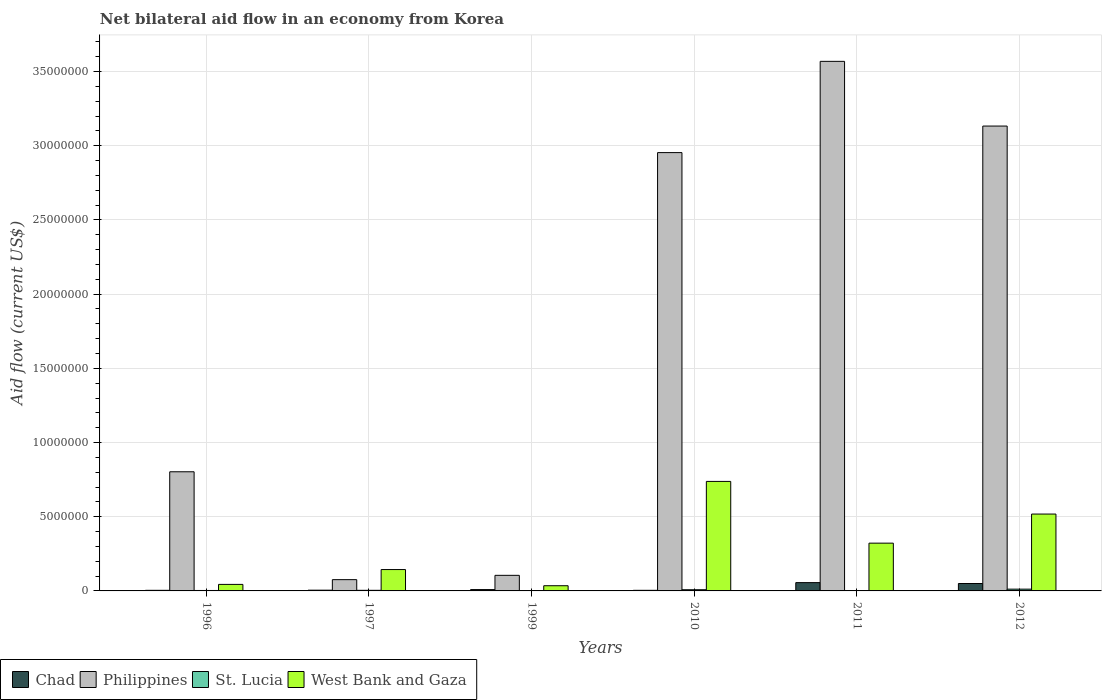How many different coloured bars are there?
Your answer should be very brief. 4. Are the number of bars per tick equal to the number of legend labels?
Keep it short and to the point. Yes. How many bars are there on the 1st tick from the left?
Offer a very short reply. 4. What is the label of the 1st group of bars from the left?
Your response must be concise. 1996. In how many cases, is the number of bars for a given year not equal to the number of legend labels?
Your response must be concise. 0. In which year was the net bilateral aid flow in Philippines maximum?
Give a very brief answer. 2011. In which year was the net bilateral aid flow in West Bank and Gaza minimum?
Offer a very short reply. 1999. What is the total net bilateral aid flow in West Bank and Gaza in the graph?
Provide a succinct answer. 1.80e+07. What is the difference between the net bilateral aid flow in Chad in 1997 and that in 2011?
Provide a succinct answer. -5.10e+05. What is the difference between the net bilateral aid flow in Chad in 1997 and the net bilateral aid flow in St. Lucia in 2012?
Keep it short and to the point. -7.00e+04. What is the average net bilateral aid flow in Philippines per year?
Provide a short and direct response. 1.77e+07. In the year 1997, what is the difference between the net bilateral aid flow in West Bank and Gaza and net bilateral aid flow in Philippines?
Provide a short and direct response. 6.80e+05. In how many years, is the net bilateral aid flow in Chad greater than 18000000 US$?
Your answer should be compact. 0. What is the ratio of the net bilateral aid flow in Chad in 1996 to that in 1999?
Make the answer very short. 0.44. Is the difference between the net bilateral aid flow in West Bank and Gaza in 1996 and 2010 greater than the difference between the net bilateral aid flow in Philippines in 1996 and 2010?
Keep it short and to the point. Yes. What is the difference between the highest and the second highest net bilateral aid flow in Philippines?
Give a very brief answer. 4.36e+06. What is the difference between the highest and the lowest net bilateral aid flow in Philippines?
Your answer should be very brief. 3.49e+07. In how many years, is the net bilateral aid flow in Chad greater than the average net bilateral aid flow in Chad taken over all years?
Make the answer very short. 2. Is the sum of the net bilateral aid flow in Philippines in 1997 and 1999 greater than the maximum net bilateral aid flow in Chad across all years?
Give a very brief answer. Yes. Is it the case that in every year, the sum of the net bilateral aid flow in Philippines and net bilateral aid flow in St. Lucia is greater than the sum of net bilateral aid flow in West Bank and Gaza and net bilateral aid flow in Chad?
Keep it short and to the point. No. What does the 1st bar from the left in 1999 represents?
Your response must be concise. Chad. What does the 1st bar from the right in 1996 represents?
Provide a succinct answer. West Bank and Gaza. Is it the case that in every year, the sum of the net bilateral aid flow in Chad and net bilateral aid flow in West Bank and Gaza is greater than the net bilateral aid flow in Philippines?
Ensure brevity in your answer.  No. Are all the bars in the graph horizontal?
Ensure brevity in your answer.  No. How many years are there in the graph?
Offer a very short reply. 6. What is the difference between two consecutive major ticks on the Y-axis?
Your response must be concise. 5.00e+06. Does the graph contain any zero values?
Give a very brief answer. No. Where does the legend appear in the graph?
Provide a short and direct response. Bottom left. How many legend labels are there?
Make the answer very short. 4. How are the legend labels stacked?
Provide a short and direct response. Horizontal. What is the title of the graph?
Your answer should be very brief. Net bilateral aid flow in an economy from Korea. What is the Aid flow (current US$) of Philippines in 1996?
Make the answer very short. 8.03e+06. What is the Aid flow (current US$) in Philippines in 1997?
Keep it short and to the point. 7.60e+05. What is the Aid flow (current US$) of West Bank and Gaza in 1997?
Make the answer very short. 1.44e+06. What is the Aid flow (current US$) of Philippines in 1999?
Offer a very short reply. 1.05e+06. What is the Aid flow (current US$) in Philippines in 2010?
Provide a succinct answer. 2.95e+07. What is the Aid flow (current US$) of St. Lucia in 2010?
Offer a terse response. 8.00e+04. What is the Aid flow (current US$) in West Bank and Gaza in 2010?
Offer a terse response. 7.38e+06. What is the Aid flow (current US$) in Chad in 2011?
Your response must be concise. 5.60e+05. What is the Aid flow (current US$) in Philippines in 2011?
Make the answer very short. 3.57e+07. What is the Aid flow (current US$) in St. Lucia in 2011?
Ensure brevity in your answer.  10000. What is the Aid flow (current US$) of West Bank and Gaza in 2011?
Provide a short and direct response. 3.22e+06. What is the Aid flow (current US$) in Chad in 2012?
Your answer should be compact. 5.00e+05. What is the Aid flow (current US$) of Philippines in 2012?
Your answer should be very brief. 3.13e+07. What is the Aid flow (current US$) of St. Lucia in 2012?
Provide a short and direct response. 1.20e+05. What is the Aid flow (current US$) in West Bank and Gaza in 2012?
Provide a short and direct response. 5.18e+06. Across all years, what is the maximum Aid flow (current US$) in Chad?
Provide a short and direct response. 5.60e+05. Across all years, what is the maximum Aid flow (current US$) of Philippines?
Make the answer very short. 3.57e+07. Across all years, what is the maximum Aid flow (current US$) in West Bank and Gaza?
Provide a short and direct response. 7.38e+06. Across all years, what is the minimum Aid flow (current US$) of Philippines?
Offer a very short reply. 7.60e+05. What is the total Aid flow (current US$) in Chad in the graph?
Provide a short and direct response. 1.28e+06. What is the total Aid flow (current US$) of Philippines in the graph?
Offer a very short reply. 1.06e+08. What is the total Aid flow (current US$) of St. Lucia in the graph?
Your answer should be very brief. 3.00e+05. What is the total Aid flow (current US$) of West Bank and Gaza in the graph?
Keep it short and to the point. 1.80e+07. What is the difference between the Aid flow (current US$) of Philippines in 1996 and that in 1997?
Your response must be concise. 7.27e+06. What is the difference between the Aid flow (current US$) of St. Lucia in 1996 and that in 1997?
Give a very brief answer. -10000. What is the difference between the Aid flow (current US$) in West Bank and Gaza in 1996 and that in 1997?
Keep it short and to the point. -1.00e+06. What is the difference between the Aid flow (current US$) of Chad in 1996 and that in 1999?
Provide a short and direct response. -5.00e+04. What is the difference between the Aid flow (current US$) of Philippines in 1996 and that in 1999?
Ensure brevity in your answer.  6.98e+06. What is the difference between the Aid flow (current US$) in Chad in 1996 and that in 2010?
Provide a succinct answer. 0. What is the difference between the Aid flow (current US$) in Philippines in 1996 and that in 2010?
Offer a very short reply. -2.15e+07. What is the difference between the Aid flow (current US$) in St. Lucia in 1996 and that in 2010?
Offer a very short reply. -5.00e+04. What is the difference between the Aid flow (current US$) in West Bank and Gaza in 1996 and that in 2010?
Your answer should be very brief. -6.94e+06. What is the difference between the Aid flow (current US$) of Chad in 1996 and that in 2011?
Offer a very short reply. -5.20e+05. What is the difference between the Aid flow (current US$) in Philippines in 1996 and that in 2011?
Offer a very short reply. -2.77e+07. What is the difference between the Aid flow (current US$) of St. Lucia in 1996 and that in 2011?
Your answer should be very brief. 2.00e+04. What is the difference between the Aid flow (current US$) in West Bank and Gaza in 1996 and that in 2011?
Provide a short and direct response. -2.78e+06. What is the difference between the Aid flow (current US$) of Chad in 1996 and that in 2012?
Make the answer very short. -4.60e+05. What is the difference between the Aid flow (current US$) in Philippines in 1996 and that in 2012?
Ensure brevity in your answer.  -2.33e+07. What is the difference between the Aid flow (current US$) of St. Lucia in 1996 and that in 2012?
Give a very brief answer. -9.00e+04. What is the difference between the Aid flow (current US$) in West Bank and Gaza in 1996 and that in 2012?
Your response must be concise. -4.74e+06. What is the difference between the Aid flow (current US$) of Chad in 1997 and that in 1999?
Your answer should be compact. -4.00e+04. What is the difference between the Aid flow (current US$) of West Bank and Gaza in 1997 and that in 1999?
Provide a succinct answer. 1.09e+06. What is the difference between the Aid flow (current US$) of Chad in 1997 and that in 2010?
Offer a terse response. 10000. What is the difference between the Aid flow (current US$) in Philippines in 1997 and that in 2010?
Keep it short and to the point. -2.88e+07. What is the difference between the Aid flow (current US$) of West Bank and Gaza in 1997 and that in 2010?
Give a very brief answer. -5.94e+06. What is the difference between the Aid flow (current US$) of Chad in 1997 and that in 2011?
Make the answer very short. -5.10e+05. What is the difference between the Aid flow (current US$) of Philippines in 1997 and that in 2011?
Make the answer very short. -3.49e+07. What is the difference between the Aid flow (current US$) of West Bank and Gaza in 1997 and that in 2011?
Offer a very short reply. -1.78e+06. What is the difference between the Aid flow (current US$) of Chad in 1997 and that in 2012?
Provide a short and direct response. -4.50e+05. What is the difference between the Aid flow (current US$) in Philippines in 1997 and that in 2012?
Provide a short and direct response. -3.06e+07. What is the difference between the Aid flow (current US$) of West Bank and Gaza in 1997 and that in 2012?
Your answer should be very brief. -3.74e+06. What is the difference between the Aid flow (current US$) in Philippines in 1999 and that in 2010?
Your response must be concise. -2.85e+07. What is the difference between the Aid flow (current US$) of St. Lucia in 1999 and that in 2010?
Make the answer very short. -6.00e+04. What is the difference between the Aid flow (current US$) of West Bank and Gaza in 1999 and that in 2010?
Make the answer very short. -7.03e+06. What is the difference between the Aid flow (current US$) in Chad in 1999 and that in 2011?
Give a very brief answer. -4.70e+05. What is the difference between the Aid flow (current US$) in Philippines in 1999 and that in 2011?
Your answer should be compact. -3.46e+07. What is the difference between the Aid flow (current US$) of St. Lucia in 1999 and that in 2011?
Offer a terse response. 10000. What is the difference between the Aid flow (current US$) of West Bank and Gaza in 1999 and that in 2011?
Provide a short and direct response. -2.87e+06. What is the difference between the Aid flow (current US$) in Chad in 1999 and that in 2012?
Make the answer very short. -4.10e+05. What is the difference between the Aid flow (current US$) of Philippines in 1999 and that in 2012?
Keep it short and to the point. -3.03e+07. What is the difference between the Aid flow (current US$) of West Bank and Gaza in 1999 and that in 2012?
Your answer should be very brief. -4.83e+06. What is the difference between the Aid flow (current US$) of Chad in 2010 and that in 2011?
Your answer should be compact. -5.20e+05. What is the difference between the Aid flow (current US$) of Philippines in 2010 and that in 2011?
Provide a succinct answer. -6.15e+06. What is the difference between the Aid flow (current US$) in St. Lucia in 2010 and that in 2011?
Provide a succinct answer. 7.00e+04. What is the difference between the Aid flow (current US$) of West Bank and Gaza in 2010 and that in 2011?
Your answer should be very brief. 4.16e+06. What is the difference between the Aid flow (current US$) in Chad in 2010 and that in 2012?
Ensure brevity in your answer.  -4.60e+05. What is the difference between the Aid flow (current US$) of Philippines in 2010 and that in 2012?
Your response must be concise. -1.79e+06. What is the difference between the Aid flow (current US$) of West Bank and Gaza in 2010 and that in 2012?
Offer a very short reply. 2.20e+06. What is the difference between the Aid flow (current US$) in Philippines in 2011 and that in 2012?
Make the answer very short. 4.36e+06. What is the difference between the Aid flow (current US$) in West Bank and Gaza in 2011 and that in 2012?
Make the answer very short. -1.96e+06. What is the difference between the Aid flow (current US$) in Chad in 1996 and the Aid flow (current US$) in Philippines in 1997?
Your answer should be compact. -7.20e+05. What is the difference between the Aid flow (current US$) in Chad in 1996 and the Aid flow (current US$) in St. Lucia in 1997?
Give a very brief answer. 0. What is the difference between the Aid flow (current US$) of Chad in 1996 and the Aid flow (current US$) of West Bank and Gaza in 1997?
Offer a very short reply. -1.40e+06. What is the difference between the Aid flow (current US$) in Philippines in 1996 and the Aid flow (current US$) in St. Lucia in 1997?
Your response must be concise. 7.99e+06. What is the difference between the Aid flow (current US$) in Philippines in 1996 and the Aid flow (current US$) in West Bank and Gaza in 1997?
Ensure brevity in your answer.  6.59e+06. What is the difference between the Aid flow (current US$) in St. Lucia in 1996 and the Aid flow (current US$) in West Bank and Gaza in 1997?
Keep it short and to the point. -1.41e+06. What is the difference between the Aid flow (current US$) in Chad in 1996 and the Aid flow (current US$) in Philippines in 1999?
Offer a terse response. -1.01e+06. What is the difference between the Aid flow (current US$) of Chad in 1996 and the Aid flow (current US$) of West Bank and Gaza in 1999?
Give a very brief answer. -3.10e+05. What is the difference between the Aid flow (current US$) in Philippines in 1996 and the Aid flow (current US$) in St. Lucia in 1999?
Offer a terse response. 8.01e+06. What is the difference between the Aid flow (current US$) of Philippines in 1996 and the Aid flow (current US$) of West Bank and Gaza in 1999?
Keep it short and to the point. 7.68e+06. What is the difference between the Aid flow (current US$) in St. Lucia in 1996 and the Aid flow (current US$) in West Bank and Gaza in 1999?
Your answer should be compact. -3.20e+05. What is the difference between the Aid flow (current US$) in Chad in 1996 and the Aid flow (current US$) in Philippines in 2010?
Your response must be concise. -2.95e+07. What is the difference between the Aid flow (current US$) of Chad in 1996 and the Aid flow (current US$) of West Bank and Gaza in 2010?
Provide a succinct answer. -7.34e+06. What is the difference between the Aid flow (current US$) in Philippines in 1996 and the Aid flow (current US$) in St. Lucia in 2010?
Provide a short and direct response. 7.95e+06. What is the difference between the Aid flow (current US$) in Philippines in 1996 and the Aid flow (current US$) in West Bank and Gaza in 2010?
Your answer should be compact. 6.50e+05. What is the difference between the Aid flow (current US$) in St. Lucia in 1996 and the Aid flow (current US$) in West Bank and Gaza in 2010?
Offer a terse response. -7.35e+06. What is the difference between the Aid flow (current US$) in Chad in 1996 and the Aid flow (current US$) in Philippines in 2011?
Provide a short and direct response. -3.56e+07. What is the difference between the Aid flow (current US$) of Chad in 1996 and the Aid flow (current US$) of West Bank and Gaza in 2011?
Provide a short and direct response. -3.18e+06. What is the difference between the Aid flow (current US$) in Philippines in 1996 and the Aid flow (current US$) in St. Lucia in 2011?
Your answer should be compact. 8.02e+06. What is the difference between the Aid flow (current US$) in Philippines in 1996 and the Aid flow (current US$) in West Bank and Gaza in 2011?
Provide a short and direct response. 4.81e+06. What is the difference between the Aid flow (current US$) of St. Lucia in 1996 and the Aid flow (current US$) of West Bank and Gaza in 2011?
Provide a short and direct response. -3.19e+06. What is the difference between the Aid flow (current US$) in Chad in 1996 and the Aid flow (current US$) in Philippines in 2012?
Offer a terse response. -3.13e+07. What is the difference between the Aid flow (current US$) of Chad in 1996 and the Aid flow (current US$) of West Bank and Gaza in 2012?
Your answer should be very brief. -5.14e+06. What is the difference between the Aid flow (current US$) of Philippines in 1996 and the Aid flow (current US$) of St. Lucia in 2012?
Provide a short and direct response. 7.91e+06. What is the difference between the Aid flow (current US$) in Philippines in 1996 and the Aid flow (current US$) in West Bank and Gaza in 2012?
Offer a terse response. 2.85e+06. What is the difference between the Aid flow (current US$) in St. Lucia in 1996 and the Aid flow (current US$) in West Bank and Gaza in 2012?
Offer a terse response. -5.15e+06. What is the difference between the Aid flow (current US$) in Chad in 1997 and the Aid flow (current US$) in St. Lucia in 1999?
Provide a succinct answer. 3.00e+04. What is the difference between the Aid flow (current US$) in Chad in 1997 and the Aid flow (current US$) in West Bank and Gaza in 1999?
Ensure brevity in your answer.  -3.00e+05. What is the difference between the Aid flow (current US$) in Philippines in 1997 and the Aid flow (current US$) in St. Lucia in 1999?
Offer a very short reply. 7.40e+05. What is the difference between the Aid flow (current US$) in St. Lucia in 1997 and the Aid flow (current US$) in West Bank and Gaza in 1999?
Your answer should be very brief. -3.10e+05. What is the difference between the Aid flow (current US$) in Chad in 1997 and the Aid flow (current US$) in Philippines in 2010?
Ensure brevity in your answer.  -2.95e+07. What is the difference between the Aid flow (current US$) of Chad in 1997 and the Aid flow (current US$) of St. Lucia in 2010?
Provide a short and direct response. -3.00e+04. What is the difference between the Aid flow (current US$) of Chad in 1997 and the Aid flow (current US$) of West Bank and Gaza in 2010?
Your answer should be very brief. -7.33e+06. What is the difference between the Aid flow (current US$) of Philippines in 1997 and the Aid flow (current US$) of St. Lucia in 2010?
Offer a very short reply. 6.80e+05. What is the difference between the Aid flow (current US$) of Philippines in 1997 and the Aid flow (current US$) of West Bank and Gaza in 2010?
Your response must be concise. -6.62e+06. What is the difference between the Aid flow (current US$) of St. Lucia in 1997 and the Aid flow (current US$) of West Bank and Gaza in 2010?
Ensure brevity in your answer.  -7.34e+06. What is the difference between the Aid flow (current US$) in Chad in 1997 and the Aid flow (current US$) in Philippines in 2011?
Ensure brevity in your answer.  -3.56e+07. What is the difference between the Aid flow (current US$) in Chad in 1997 and the Aid flow (current US$) in West Bank and Gaza in 2011?
Offer a very short reply. -3.17e+06. What is the difference between the Aid flow (current US$) in Philippines in 1997 and the Aid flow (current US$) in St. Lucia in 2011?
Provide a short and direct response. 7.50e+05. What is the difference between the Aid flow (current US$) of Philippines in 1997 and the Aid flow (current US$) of West Bank and Gaza in 2011?
Your answer should be very brief. -2.46e+06. What is the difference between the Aid flow (current US$) in St. Lucia in 1997 and the Aid flow (current US$) in West Bank and Gaza in 2011?
Your response must be concise. -3.18e+06. What is the difference between the Aid flow (current US$) in Chad in 1997 and the Aid flow (current US$) in Philippines in 2012?
Provide a short and direct response. -3.13e+07. What is the difference between the Aid flow (current US$) of Chad in 1997 and the Aid flow (current US$) of St. Lucia in 2012?
Make the answer very short. -7.00e+04. What is the difference between the Aid flow (current US$) of Chad in 1997 and the Aid flow (current US$) of West Bank and Gaza in 2012?
Give a very brief answer. -5.13e+06. What is the difference between the Aid flow (current US$) in Philippines in 1997 and the Aid flow (current US$) in St. Lucia in 2012?
Give a very brief answer. 6.40e+05. What is the difference between the Aid flow (current US$) of Philippines in 1997 and the Aid flow (current US$) of West Bank and Gaza in 2012?
Make the answer very short. -4.42e+06. What is the difference between the Aid flow (current US$) in St. Lucia in 1997 and the Aid flow (current US$) in West Bank and Gaza in 2012?
Offer a terse response. -5.14e+06. What is the difference between the Aid flow (current US$) of Chad in 1999 and the Aid flow (current US$) of Philippines in 2010?
Offer a terse response. -2.94e+07. What is the difference between the Aid flow (current US$) in Chad in 1999 and the Aid flow (current US$) in St. Lucia in 2010?
Offer a very short reply. 10000. What is the difference between the Aid flow (current US$) in Chad in 1999 and the Aid flow (current US$) in West Bank and Gaza in 2010?
Make the answer very short. -7.29e+06. What is the difference between the Aid flow (current US$) of Philippines in 1999 and the Aid flow (current US$) of St. Lucia in 2010?
Give a very brief answer. 9.70e+05. What is the difference between the Aid flow (current US$) of Philippines in 1999 and the Aid flow (current US$) of West Bank and Gaza in 2010?
Make the answer very short. -6.33e+06. What is the difference between the Aid flow (current US$) of St. Lucia in 1999 and the Aid flow (current US$) of West Bank and Gaza in 2010?
Give a very brief answer. -7.36e+06. What is the difference between the Aid flow (current US$) in Chad in 1999 and the Aid flow (current US$) in Philippines in 2011?
Your answer should be very brief. -3.56e+07. What is the difference between the Aid flow (current US$) of Chad in 1999 and the Aid flow (current US$) of West Bank and Gaza in 2011?
Make the answer very short. -3.13e+06. What is the difference between the Aid flow (current US$) of Philippines in 1999 and the Aid flow (current US$) of St. Lucia in 2011?
Provide a succinct answer. 1.04e+06. What is the difference between the Aid flow (current US$) in Philippines in 1999 and the Aid flow (current US$) in West Bank and Gaza in 2011?
Make the answer very short. -2.17e+06. What is the difference between the Aid flow (current US$) of St. Lucia in 1999 and the Aid flow (current US$) of West Bank and Gaza in 2011?
Your response must be concise. -3.20e+06. What is the difference between the Aid flow (current US$) in Chad in 1999 and the Aid flow (current US$) in Philippines in 2012?
Provide a short and direct response. -3.12e+07. What is the difference between the Aid flow (current US$) in Chad in 1999 and the Aid flow (current US$) in St. Lucia in 2012?
Your response must be concise. -3.00e+04. What is the difference between the Aid flow (current US$) of Chad in 1999 and the Aid flow (current US$) of West Bank and Gaza in 2012?
Keep it short and to the point. -5.09e+06. What is the difference between the Aid flow (current US$) in Philippines in 1999 and the Aid flow (current US$) in St. Lucia in 2012?
Keep it short and to the point. 9.30e+05. What is the difference between the Aid flow (current US$) in Philippines in 1999 and the Aid flow (current US$) in West Bank and Gaza in 2012?
Provide a succinct answer. -4.13e+06. What is the difference between the Aid flow (current US$) in St. Lucia in 1999 and the Aid flow (current US$) in West Bank and Gaza in 2012?
Your answer should be very brief. -5.16e+06. What is the difference between the Aid flow (current US$) of Chad in 2010 and the Aid flow (current US$) of Philippines in 2011?
Ensure brevity in your answer.  -3.56e+07. What is the difference between the Aid flow (current US$) of Chad in 2010 and the Aid flow (current US$) of West Bank and Gaza in 2011?
Your response must be concise. -3.18e+06. What is the difference between the Aid flow (current US$) of Philippines in 2010 and the Aid flow (current US$) of St. Lucia in 2011?
Keep it short and to the point. 2.95e+07. What is the difference between the Aid flow (current US$) in Philippines in 2010 and the Aid flow (current US$) in West Bank and Gaza in 2011?
Make the answer very short. 2.63e+07. What is the difference between the Aid flow (current US$) of St. Lucia in 2010 and the Aid flow (current US$) of West Bank and Gaza in 2011?
Provide a short and direct response. -3.14e+06. What is the difference between the Aid flow (current US$) in Chad in 2010 and the Aid flow (current US$) in Philippines in 2012?
Keep it short and to the point. -3.13e+07. What is the difference between the Aid flow (current US$) of Chad in 2010 and the Aid flow (current US$) of West Bank and Gaza in 2012?
Provide a succinct answer. -5.14e+06. What is the difference between the Aid flow (current US$) of Philippines in 2010 and the Aid flow (current US$) of St. Lucia in 2012?
Give a very brief answer. 2.94e+07. What is the difference between the Aid flow (current US$) in Philippines in 2010 and the Aid flow (current US$) in West Bank and Gaza in 2012?
Offer a very short reply. 2.44e+07. What is the difference between the Aid flow (current US$) of St. Lucia in 2010 and the Aid flow (current US$) of West Bank and Gaza in 2012?
Provide a short and direct response. -5.10e+06. What is the difference between the Aid flow (current US$) of Chad in 2011 and the Aid flow (current US$) of Philippines in 2012?
Your answer should be compact. -3.08e+07. What is the difference between the Aid flow (current US$) of Chad in 2011 and the Aid flow (current US$) of West Bank and Gaza in 2012?
Keep it short and to the point. -4.62e+06. What is the difference between the Aid flow (current US$) in Philippines in 2011 and the Aid flow (current US$) in St. Lucia in 2012?
Offer a terse response. 3.56e+07. What is the difference between the Aid flow (current US$) in Philippines in 2011 and the Aid flow (current US$) in West Bank and Gaza in 2012?
Ensure brevity in your answer.  3.05e+07. What is the difference between the Aid flow (current US$) of St. Lucia in 2011 and the Aid flow (current US$) of West Bank and Gaza in 2012?
Provide a succinct answer. -5.17e+06. What is the average Aid flow (current US$) of Chad per year?
Your answer should be compact. 2.13e+05. What is the average Aid flow (current US$) of Philippines per year?
Your response must be concise. 1.77e+07. What is the average Aid flow (current US$) in St. Lucia per year?
Your response must be concise. 5.00e+04. What is the average Aid flow (current US$) in West Bank and Gaza per year?
Give a very brief answer. 3.00e+06. In the year 1996, what is the difference between the Aid flow (current US$) of Chad and Aid flow (current US$) of Philippines?
Offer a terse response. -7.99e+06. In the year 1996, what is the difference between the Aid flow (current US$) in Chad and Aid flow (current US$) in West Bank and Gaza?
Provide a short and direct response. -4.00e+05. In the year 1996, what is the difference between the Aid flow (current US$) of Philippines and Aid flow (current US$) of St. Lucia?
Offer a very short reply. 8.00e+06. In the year 1996, what is the difference between the Aid flow (current US$) in Philippines and Aid flow (current US$) in West Bank and Gaza?
Make the answer very short. 7.59e+06. In the year 1996, what is the difference between the Aid flow (current US$) of St. Lucia and Aid flow (current US$) of West Bank and Gaza?
Your answer should be compact. -4.10e+05. In the year 1997, what is the difference between the Aid flow (current US$) of Chad and Aid flow (current US$) of Philippines?
Offer a terse response. -7.10e+05. In the year 1997, what is the difference between the Aid flow (current US$) of Chad and Aid flow (current US$) of West Bank and Gaza?
Your answer should be very brief. -1.39e+06. In the year 1997, what is the difference between the Aid flow (current US$) in Philippines and Aid flow (current US$) in St. Lucia?
Your answer should be compact. 7.20e+05. In the year 1997, what is the difference between the Aid flow (current US$) in Philippines and Aid flow (current US$) in West Bank and Gaza?
Keep it short and to the point. -6.80e+05. In the year 1997, what is the difference between the Aid flow (current US$) in St. Lucia and Aid flow (current US$) in West Bank and Gaza?
Make the answer very short. -1.40e+06. In the year 1999, what is the difference between the Aid flow (current US$) of Chad and Aid flow (current US$) of Philippines?
Your response must be concise. -9.60e+05. In the year 1999, what is the difference between the Aid flow (current US$) of Philippines and Aid flow (current US$) of St. Lucia?
Ensure brevity in your answer.  1.03e+06. In the year 1999, what is the difference between the Aid flow (current US$) in St. Lucia and Aid flow (current US$) in West Bank and Gaza?
Provide a short and direct response. -3.30e+05. In the year 2010, what is the difference between the Aid flow (current US$) of Chad and Aid flow (current US$) of Philippines?
Offer a very short reply. -2.95e+07. In the year 2010, what is the difference between the Aid flow (current US$) of Chad and Aid flow (current US$) of St. Lucia?
Your response must be concise. -4.00e+04. In the year 2010, what is the difference between the Aid flow (current US$) of Chad and Aid flow (current US$) of West Bank and Gaza?
Ensure brevity in your answer.  -7.34e+06. In the year 2010, what is the difference between the Aid flow (current US$) in Philippines and Aid flow (current US$) in St. Lucia?
Your answer should be very brief. 2.95e+07. In the year 2010, what is the difference between the Aid flow (current US$) in Philippines and Aid flow (current US$) in West Bank and Gaza?
Offer a very short reply. 2.22e+07. In the year 2010, what is the difference between the Aid flow (current US$) of St. Lucia and Aid flow (current US$) of West Bank and Gaza?
Make the answer very short. -7.30e+06. In the year 2011, what is the difference between the Aid flow (current US$) of Chad and Aid flow (current US$) of Philippines?
Give a very brief answer. -3.51e+07. In the year 2011, what is the difference between the Aid flow (current US$) in Chad and Aid flow (current US$) in West Bank and Gaza?
Provide a short and direct response. -2.66e+06. In the year 2011, what is the difference between the Aid flow (current US$) of Philippines and Aid flow (current US$) of St. Lucia?
Your answer should be compact. 3.57e+07. In the year 2011, what is the difference between the Aid flow (current US$) of Philippines and Aid flow (current US$) of West Bank and Gaza?
Keep it short and to the point. 3.25e+07. In the year 2011, what is the difference between the Aid flow (current US$) in St. Lucia and Aid flow (current US$) in West Bank and Gaza?
Offer a very short reply. -3.21e+06. In the year 2012, what is the difference between the Aid flow (current US$) of Chad and Aid flow (current US$) of Philippines?
Provide a succinct answer. -3.08e+07. In the year 2012, what is the difference between the Aid flow (current US$) in Chad and Aid flow (current US$) in St. Lucia?
Your answer should be very brief. 3.80e+05. In the year 2012, what is the difference between the Aid flow (current US$) in Chad and Aid flow (current US$) in West Bank and Gaza?
Give a very brief answer. -4.68e+06. In the year 2012, what is the difference between the Aid flow (current US$) of Philippines and Aid flow (current US$) of St. Lucia?
Provide a short and direct response. 3.12e+07. In the year 2012, what is the difference between the Aid flow (current US$) in Philippines and Aid flow (current US$) in West Bank and Gaza?
Ensure brevity in your answer.  2.62e+07. In the year 2012, what is the difference between the Aid flow (current US$) of St. Lucia and Aid flow (current US$) of West Bank and Gaza?
Offer a very short reply. -5.06e+06. What is the ratio of the Aid flow (current US$) in Chad in 1996 to that in 1997?
Provide a succinct answer. 0.8. What is the ratio of the Aid flow (current US$) in Philippines in 1996 to that in 1997?
Make the answer very short. 10.57. What is the ratio of the Aid flow (current US$) of West Bank and Gaza in 1996 to that in 1997?
Provide a short and direct response. 0.31. What is the ratio of the Aid flow (current US$) of Chad in 1996 to that in 1999?
Make the answer very short. 0.44. What is the ratio of the Aid flow (current US$) in Philippines in 1996 to that in 1999?
Offer a terse response. 7.65. What is the ratio of the Aid flow (current US$) in West Bank and Gaza in 1996 to that in 1999?
Make the answer very short. 1.26. What is the ratio of the Aid flow (current US$) in Philippines in 1996 to that in 2010?
Provide a short and direct response. 0.27. What is the ratio of the Aid flow (current US$) in St. Lucia in 1996 to that in 2010?
Provide a succinct answer. 0.38. What is the ratio of the Aid flow (current US$) in West Bank and Gaza in 1996 to that in 2010?
Your answer should be compact. 0.06. What is the ratio of the Aid flow (current US$) of Chad in 1996 to that in 2011?
Your answer should be very brief. 0.07. What is the ratio of the Aid flow (current US$) in Philippines in 1996 to that in 2011?
Make the answer very short. 0.23. What is the ratio of the Aid flow (current US$) of St. Lucia in 1996 to that in 2011?
Offer a very short reply. 3. What is the ratio of the Aid flow (current US$) in West Bank and Gaza in 1996 to that in 2011?
Your answer should be compact. 0.14. What is the ratio of the Aid flow (current US$) of Philippines in 1996 to that in 2012?
Your response must be concise. 0.26. What is the ratio of the Aid flow (current US$) in West Bank and Gaza in 1996 to that in 2012?
Your answer should be very brief. 0.08. What is the ratio of the Aid flow (current US$) of Chad in 1997 to that in 1999?
Provide a short and direct response. 0.56. What is the ratio of the Aid flow (current US$) in Philippines in 1997 to that in 1999?
Offer a very short reply. 0.72. What is the ratio of the Aid flow (current US$) in West Bank and Gaza in 1997 to that in 1999?
Your answer should be very brief. 4.11. What is the ratio of the Aid flow (current US$) of Chad in 1997 to that in 2010?
Ensure brevity in your answer.  1.25. What is the ratio of the Aid flow (current US$) in Philippines in 1997 to that in 2010?
Offer a terse response. 0.03. What is the ratio of the Aid flow (current US$) of St. Lucia in 1997 to that in 2010?
Your answer should be very brief. 0.5. What is the ratio of the Aid flow (current US$) of West Bank and Gaza in 1997 to that in 2010?
Your response must be concise. 0.2. What is the ratio of the Aid flow (current US$) of Chad in 1997 to that in 2011?
Give a very brief answer. 0.09. What is the ratio of the Aid flow (current US$) of Philippines in 1997 to that in 2011?
Provide a short and direct response. 0.02. What is the ratio of the Aid flow (current US$) in St. Lucia in 1997 to that in 2011?
Give a very brief answer. 4. What is the ratio of the Aid flow (current US$) of West Bank and Gaza in 1997 to that in 2011?
Offer a terse response. 0.45. What is the ratio of the Aid flow (current US$) of Chad in 1997 to that in 2012?
Your response must be concise. 0.1. What is the ratio of the Aid flow (current US$) in Philippines in 1997 to that in 2012?
Your answer should be very brief. 0.02. What is the ratio of the Aid flow (current US$) in West Bank and Gaza in 1997 to that in 2012?
Your answer should be compact. 0.28. What is the ratio of the Aid flow (current US$) of Chad in 1999 to that in 2010?
Give a very brief answer. 2.25. What is the ratio of the Aid flow (current US$) of Philippines in 1999 to that in 2010?
Your response must be concise. 0.04. What is the ratio of the Aid flow (current US$) in St. Lucia in 1999 to that in 2010?
Provide a succinct answer. 0.25. What is the ratio of the Aid flow (current US$) of West Bank and Gaza in 1999 to that in 2010?
Keep it short and to the point. 0.05. What is the ratio of the Aid flow (current US$) of Chad in 1999 to that in 2011?
Give a very brief answer. 0.16. What is the ratio of the Aid flow (current US$) of Philippines in 1999 to that in 2011?
Make the answer very short. 0.03. What is the ratio of the Aid flow (current US$) of St. Lucia in 1999 to that in 2011?
Provide a succinct answer. 2. What is the ratio of the Aid flow (current US$) in West Bank and Gaza in 1999 to that in 2011?
Keep it short and to the point. 0.11. What is the ratio of the Aid flow (current US$) in Chad in 1999 to that in 2012?
Give a very brief answer. 0.18. What is the ratio of the Aid flow (current US$) in Philippines in 1999 to that in 2012?
Provide a succinct answer. 0.03. What is the ratio of the Aid flow (current US$) in West Bank and Gaza in 1999 to that in 2012?
Your response must be concise. 0.07. What is the ratio of the Aid flow (current US$) in Chad in 2010 to that in 2011?
Ensure brevity in your answer.  0.07. What is the ratio of the Aid flow (current US$) of Philippines in 2010 to that in 2011?
Your response must be concise. 0.83. What is the ratio of the Aid flow (current US$) in West Bank and Gaza in 2010 to that in 2011?
Your response must be concise. 2.29. What is the ratio of the Aid flow (current US$) in Philippines in 2010 to that in 2012?
Your answer should be compact. 0.94. What is the ratio of the Aid flow (current US$) in St. Lucia in 2010 to that in 2012?
Keep it short and to the point. 0.67. What is the ratio of the Aid flow (current US$) in West Bank and Gaza in 2010 to that in 2012?
Provide a short and direct response. 1.42. What is the ratio of the Aid flow (current US$) in Chad in 2011 to that in 2012?
Give a very brief answer. 1.12. What is the ratio of the Aid flow (current US$) in Philippines in 2011 to that in 2012?
Your answer should be very brief. 1.14. What is the ratio of the Aid flow (current US$) of St. Lucia in 2011 to that in 2012?
Offer a very short reply. 0.08. What is the ratio of the Aid flow (current US$) of West Bank and Gaza in 2011 to that in 2012?
Provide a succinct answer. 0.62. What is the difference between the highest and the second highest Aid flow (current US$) of Philippines?
Provide a short and direct response. 4.36e+06. What is the difference between the highest and the second highest Aid flow (current US$) in West Bank and Gaza?
Your answer should be compact. 2.20e+06. What is the difference between the highest and the lowest Aid flow (current US$) of Chad?
Offer a terse response. 5.20e+05. What is the difference between the highest and the lowest Aid flow (current US$) in Philippines?
Your response must be concise. 3.49e+07. What is the difference between the highest and the lowest Aid flow (current US$) in St. Lucia?
Keep it short and to the point. 1.10e+05. What is the difference between the highest and the lowest Aid flow (current US$) in West Bank and Gaza?
Your answer should be compact. 7.03e+06. 